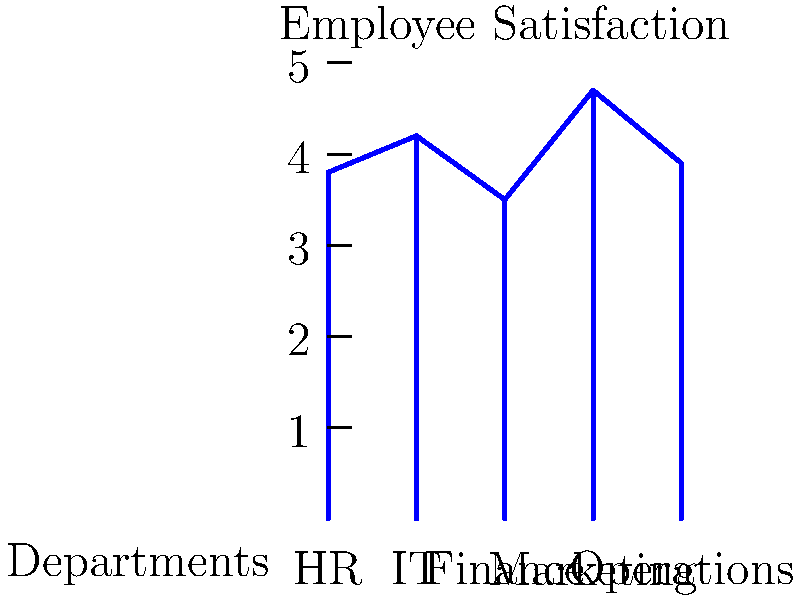As an organizational psychologist, you're analyzing employee satisfaction levels across different departments. The bar graph shows satisfaction scores on a scale of 1 to 5 for five departments. What is the difference between the highest and lowest satisfaction scores, and which departments do they represent? To solve this problem, we need to follow these steps:

1. Identify the highest satisfaction score:
   Looking at the graph, we can see that Marketing has the highest bar, reaching 4.7 on the scale.

2. Identify the lowest satisfaction score:
   The lowest bar corresponds to Finance, with a score of 3.5.

3. Calculate the difference:
   $$ \text{Difference} = \text{Highest score} - \text{Lowest score} $$
   $$ \text{Difference} = 4.7 - 3.5 = 1.2 $$

4. Identify the departments:
   Highest satisfaction: Marketing
   Lowest satisfaction: Finance

Therefore, the difference between the highest and lowest satisfaction scores is 1.2, with Marketing having the highest score and Finance having the lowest.
Answer: 1.2; Marketing (highest) and Finance (lowest) 